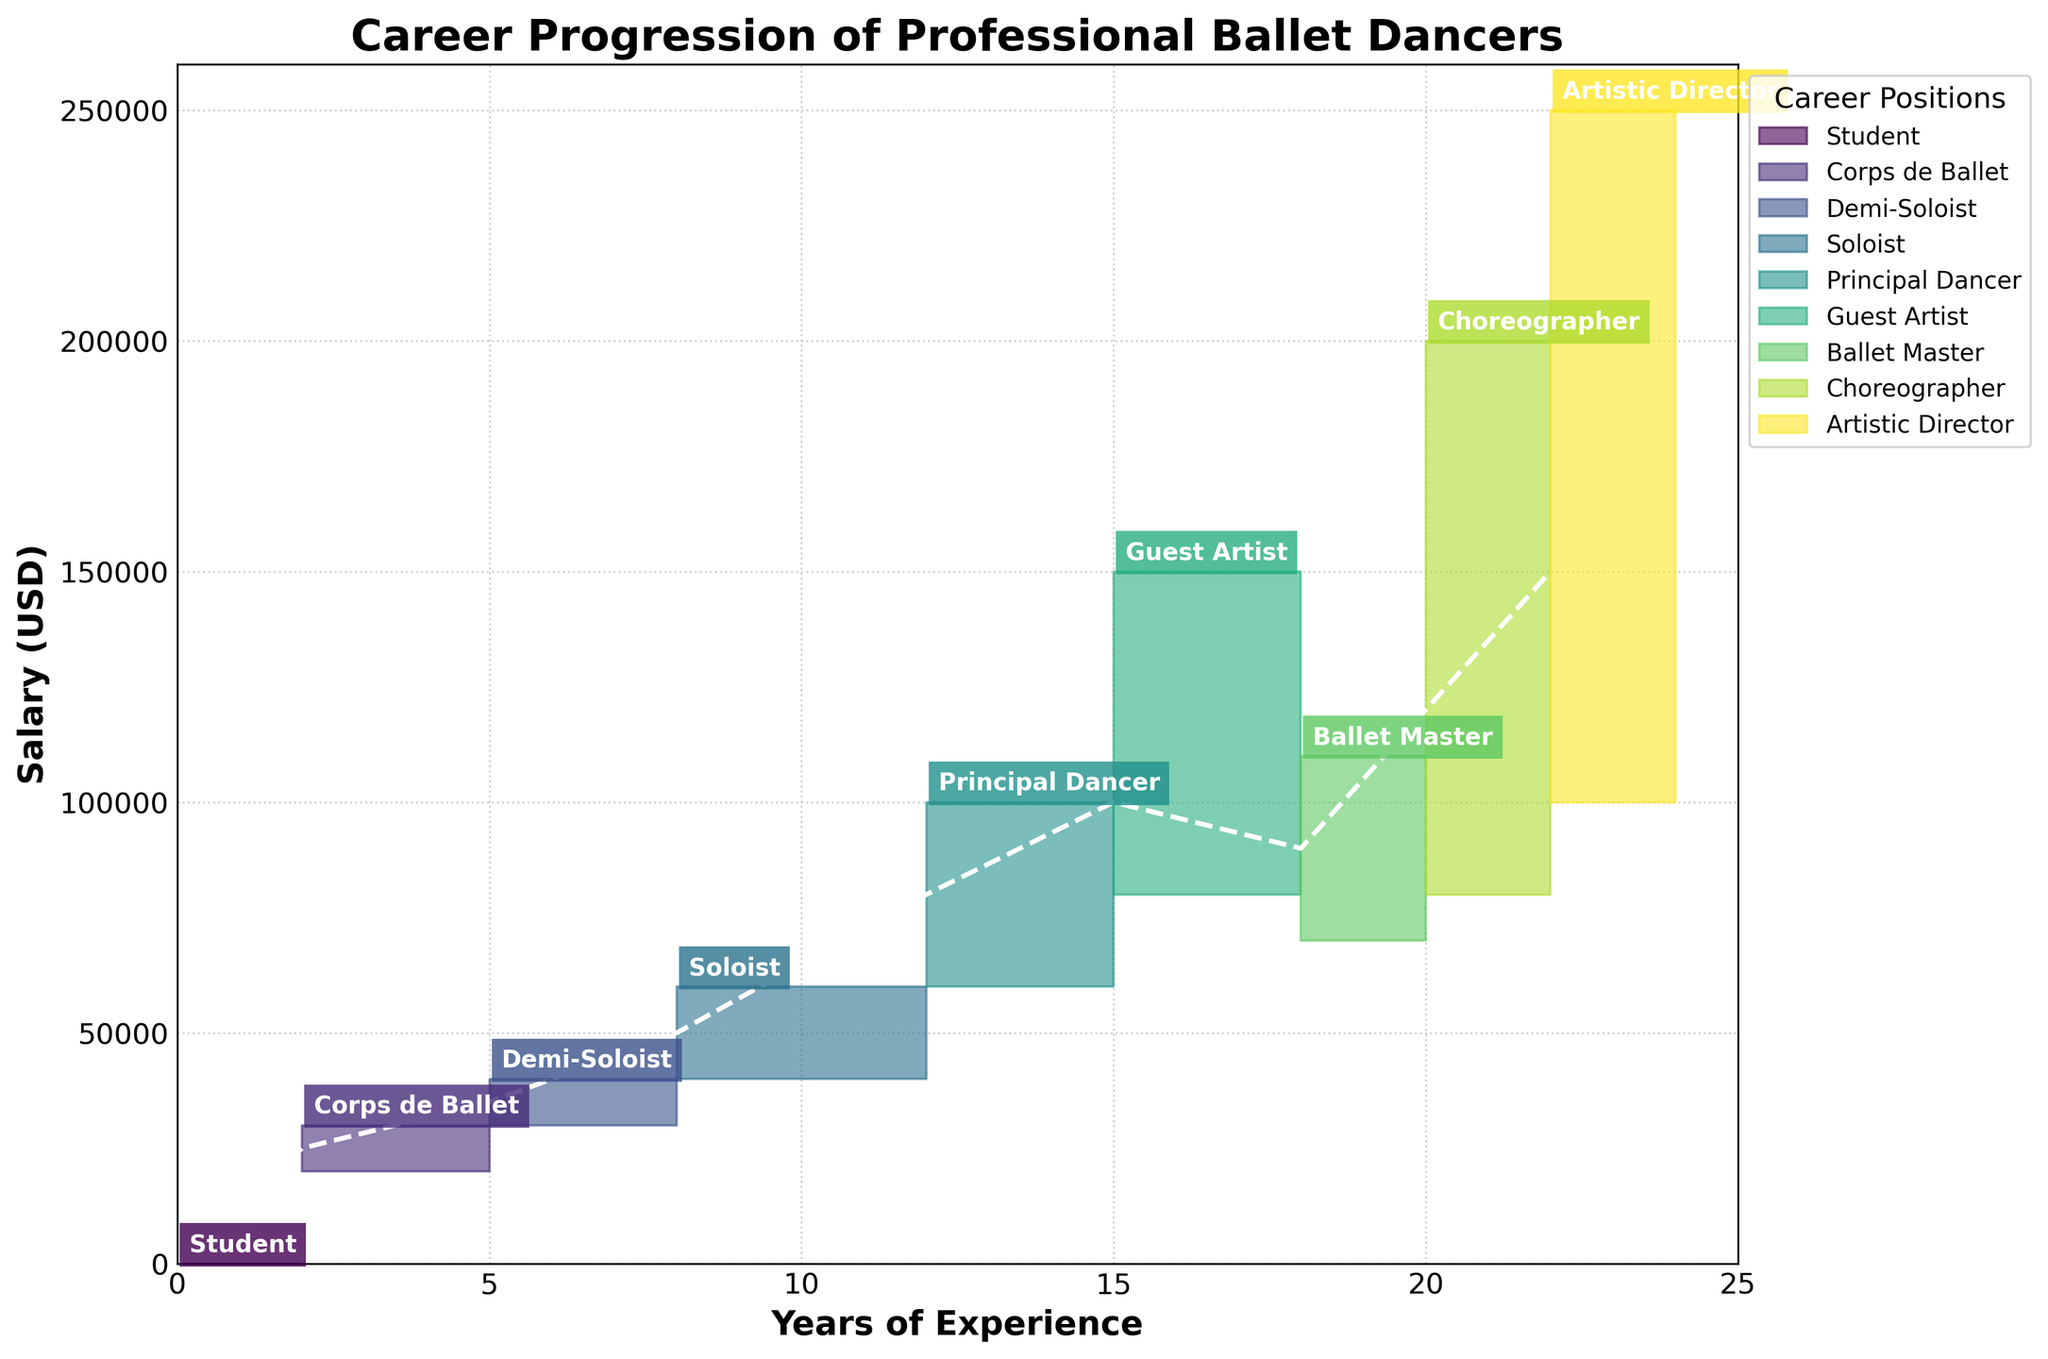What's the title of the figure? The title is typically placed at the top of the figure. In this case, it reads "Career Progression of Professional Ballet Dancers."
Answer: Career Progression of Professional Ballet Dancers What do the x-axis and y-axis represent? The x-axis, labeled "Years of Experience," indicates the progression of years. The y-axis, labeled "Salary (USD)," shows the salary range in U.S. dollars.
Answer: Years of Experience; Salary (USD) What is the salary range for a Soloist? To find the salary range, look at the "Soloist" position on the chart. The bottom line represents the low salary (40,000), and the top line represents the high salary (60,000).
Answer: $40,000 to $60,000 How many career stages are depicted in the figure? Each career stage is labeled and marked on the chart, starting from "Student" to "Artistic Director." Count these labeled stages.
Answer: 9 stages What is the mid-salary for a Principal Dancer? Locate the "Principal Dancer" position and refer to the middle line representing the mid-salary, which is typically highlighted.
Answer: $80,000 What is the difference in high salary between a Corps de Ballet dancer and an Artistic Director? The high salary for the Corps de Ballet is $30,000, and for the Artistic Director, it is $250,000. Subtract these two values: $250,000 - $30,000.
Answer: $220,000 Which position has the highest potential salary and what is it? Scan the top of the y-axis value across all positions. The position "Artistic Director" has the highest potential salary of $250,000.
Answer: Artistic Director, $250,000 How does the salary of a Guest Artist compare to that of a Principal Dancer? Compare the salary ranges for both positions. Guest Artist's range: $80,000 to $150,000. Principal Dancer's range: $60,000 to $100,000. The Guest Artist has both a higher low and high salary.
Answer: Higher What is the average high salary between the Ballet Master and Choreographer positions? High salaries: Ballet Master: $110,000, Choreographer: $200,000. Sum these values and divide by 2: (110,000 + 200,000) / 2.
Answer: $155,000 How many years of experience are needed to achieve the position of Artistic Director? Refer to the x-axis value for the "Artistic Director" label. It is positioned at 22 years of experience.
Answer: 22 years of experience 